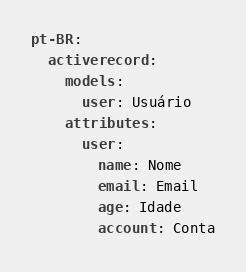<code> <loc_0><loc_0><loc_500><loc_500><_YAML_>pt-BR:
  activerecord:
    models:
      user: Usuário
    attributes:
      user:
        name: Nome
        email: Email
        age: Idade
        account: Conta
</code> 